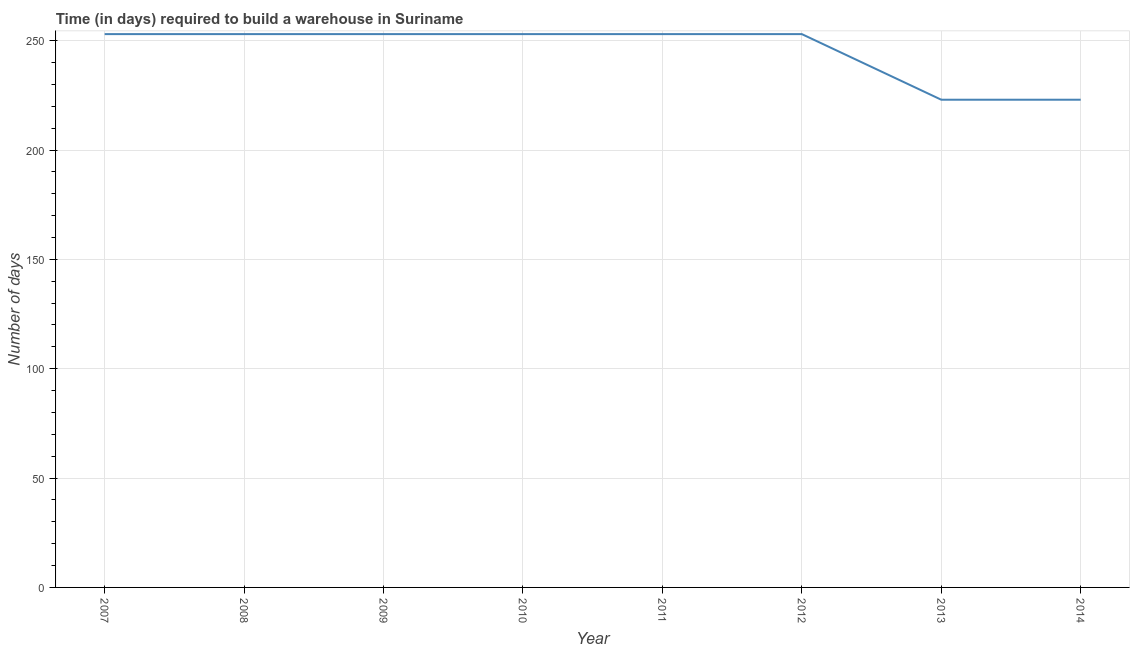What is the time required to build a warehouse in 2011?
Keep it short and to the point. 253. Across all years, what is the maximum time required to build a warehouse?
Keep it short and to the point. 253. Across all years, what is the minimum time required to build a warehouse?
Offer a very short reply. 223. In which year was the time required to build a warehouse maximum?
Your answer should be very brief. 2007. What is the sum of the time required to build a warehouse?
Provide a short and direct response. 1964. What is the average time required to build a warehouse per year?
Provide a succinct answer. 245.5. What is the median time required to build a warehouse?
Offer a terse response. 253. Do a majority of the years between 2012 and 2007 (inclusive) have time required to build a warehouse greater than 180 days?
Your answer should be very brief. Yes. What is the ratio of the time required to build a warehouse in 2011 to that in 2013?
Give a very brief answer. 1.13. Is the time required to build a warehouse in 2009 less than that in 2012?
Your response must be concise. No. Is the difference between the time required to build a warehouse in 2009 and 2011 greater than the difference between any two years?
Offer a very short reply. No. Is the sum of the time required to build a warehouse in 2010 and 2013 greater than the maximum time required to build a warehouse across all years?
Your response must be concise. Yes. What is the difference between the highest and the lowest time required to build a warehouse?
Keep it short and to the point. 30. In how many years, is the time required to build a warehouse greater than the average time required to build a warehouse taken over all years?
Make the answer very short. 6. How many lines are there?
Your answer should be compact. 1. How many years are there in the graph?
Keep it short and to the point. 8. Does the graph contain any zero values?
Give a very brief answer. No. Does the graph contain grids?
Keep it short and to the point. Yes. What is the title of the graph?
Keep it short and to the point. Time (in days) required to build a warehouse in Suriname. What is the label or title of the X-axis?
Your answer should be very brief. Year. What is the label or title of the Y-axis?
Provide a succinct answer. Number of days. What is the Number of days in 2007?
Give a very brief answer. 253. What is the Number of days of 2008?
Your answer should be very brief. 253. What is the Number of days in 2009?
Make the answer very short. 253. What is the Number of days in 2010?
Keep it short and to the point. 253. What is the Number of days in 2011?
Keep it short and to the point. 253. What is the Number of days of 2012?
Provide a succinct answer. 253. What is the Number of days of 2013?
Provide a succinct answer. 223. What is the Number of days of 2014?
Give a very brief answer. 223. What is the difference between the Number of days in 2007 and 2008?
Offer a very short reply. 0. What is the difference between the Number of days in 2007 and 2009?
Provide a succinct answer. 0. What is the difference between the Number of days in 2007 and 2010?
Provide a short and direct response. 0. What is the difference between the Number of days in 2007 and 2011?
Keep it short and to the point. 0. What is the difference between the Number of days in 2007 and 2012?
Make the answer very short. 0. What is the difference between the Number of days in 2007 and 2013?
Make the answer very short. 30. What is the difference between the Number of days in 2007 and 2014?
Keep it short and to the point. 30. What is the difference between the Number of days in 2008 and 2009?
Keep it short and to the point. 0. What is the difference between the Number of days in 2008 and 2012?
Your answer should be very brief. 0. What is the difference between the Number of days in 2008 and 2013?
Make the answer very short. 30. What is the difference between the Number of days in 2008 and 2014?
Offer a very short reply. 30. What is the difference between the Number of days in 2009 and 2013?
Offer a very short reply. 30. What is the difference between the Number of days in 2011 and 2012?
Ensure brevity in your answer.  0. What is the difference between the Number of days in 2012 and 2013?
Provide a short and direct response. 30. What is the difference between the Number of days in 2013 and 2014?
Keep it short and to the point. 0. What is the ratio of the Number of days in 2007 to that in 2009?
Offer a very short reply. 1. What is the ratio of the Number of days in 2007 to that in 2011?
Make the answer very short. 1. What is the ratio of the Number of days in 2007 to that in 2013?
Give a very brief answer. 1.14. What is the ratio of the Number of days in 2007 to that in 2014?
Keep it short and to the point. 1.14. What is the ratio of the Number of days in 2008 to that in 2011?
Give a very brief answer. 1. What is the ratio of the Number of days in 2008 to that in 2012?
Provide a succinct answer. 1. What is the ratio of the Number of days in 2008 to that in 2013?
Offer a terse response. 1.14. What is the ratio of the Number of days in 2008 to that in 2014?
Offer a terse response. 1.14. What is the ratio of the Number of days in 2009 to that in 2010?
Offer a terse response. 1. What is the ratio of the Number of days in 2009 to that in 2013?
Your answer should be very brief. 1.14. What is the ratio of the Number of days in 2009 to that in 2014?
Ensure brevity in your answer.  1.14. What is the ratio of the Number of days in 2010 to that in 2013?
Keep it short and to the point. 1.14. What is the ratio of the Number of days in 2010 to that in 2014?
Offer a terse response. 1.14. What is the ratio of the Number of days in 2011 to that in 2013?
Your answer should be very brief. 1.14. What is the ratio of the Number of days in 2011 to that in 2014?
Your response must be concise. 1.14. What is the ratio of the Number of days in 2012 to that in 2013?
Your answer should be very brief. 1.14. What is the ratio of the Number of days in 2012 to that in 2014?
Ensure brevity in your answer.  1.14. What is the ratio of the Number of days in 2013 to that in 2014?
Make the answer very short. 1. 